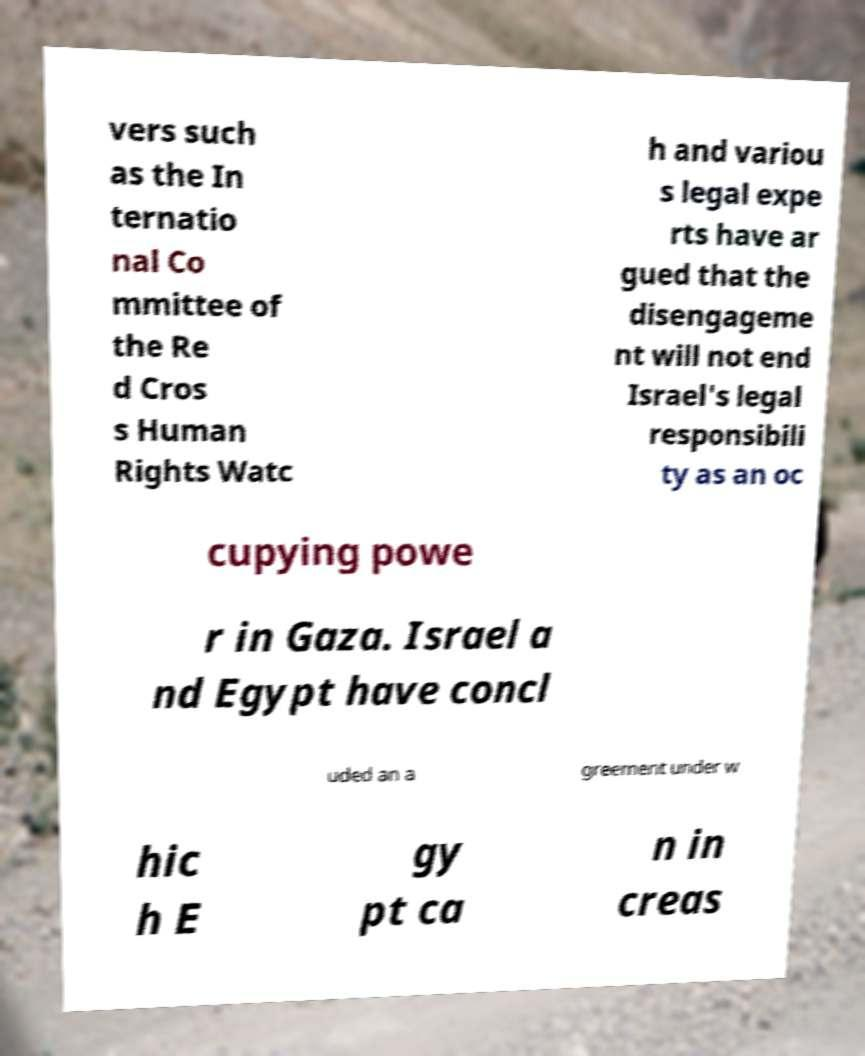Could you assist in decoding the text presented in this image and type it out clearly? vers such as the In ternatio nal Co mmittee of the Re d Cros s Human Rights Watc h and variou s legal expe rts have ar gued that the disengageme nt will not end Israel's legal responsibili ty as an oc cupying powe r in Gaza. Israel a nd Egypt have concl uded an a greement under w hic h E gy pt ca n in creas 